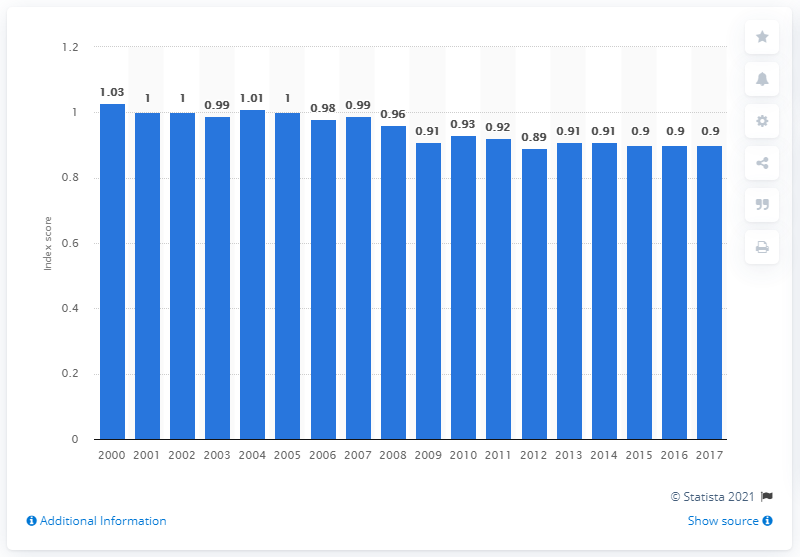Indicate a few pertinent items in this graphic. The per capita energy consumption in the United States in 2017 was 0.9. 